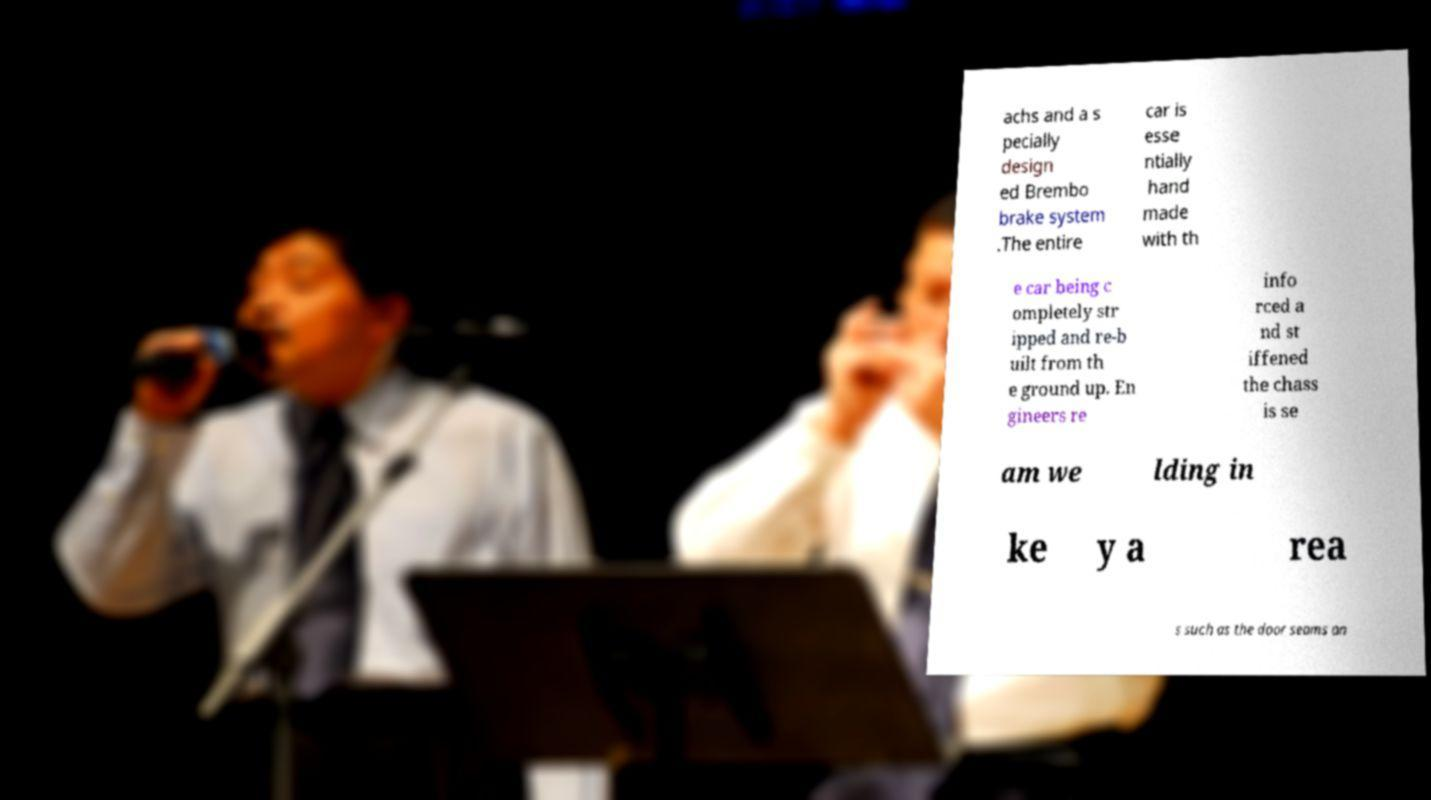What messages or text are displayed in this image? I need them in a readable, typed format. achs and a s pecially design ed Brembo brake system .The entire car is esse ntially hand made with th e car being c ompletely str ipped and re-b uilt from th e ground up. En gineers re info rced a nd st iffened the chass is se am we lding in ke y a rea s such as the door seams an 